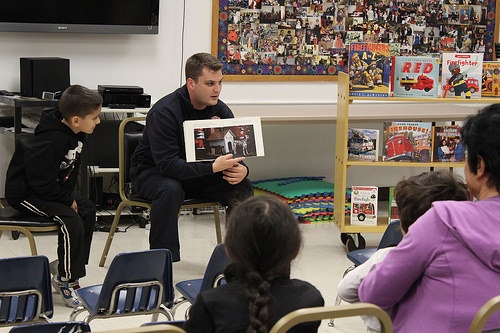<image>
Can you confirm if the man is behind the book? Yes. From this viewpoint, the man is positioned behind the book, with the book partially or fully occluding the man. Is there a book to the right of the man? Yes. From this viewpoint, the book is positioned to the right side relative to the man. Where is the book in relation to the foam? Is it in front of the foam? Yes. The book is positioned in front of the foam, appearing closer to the camera viewpoint. 